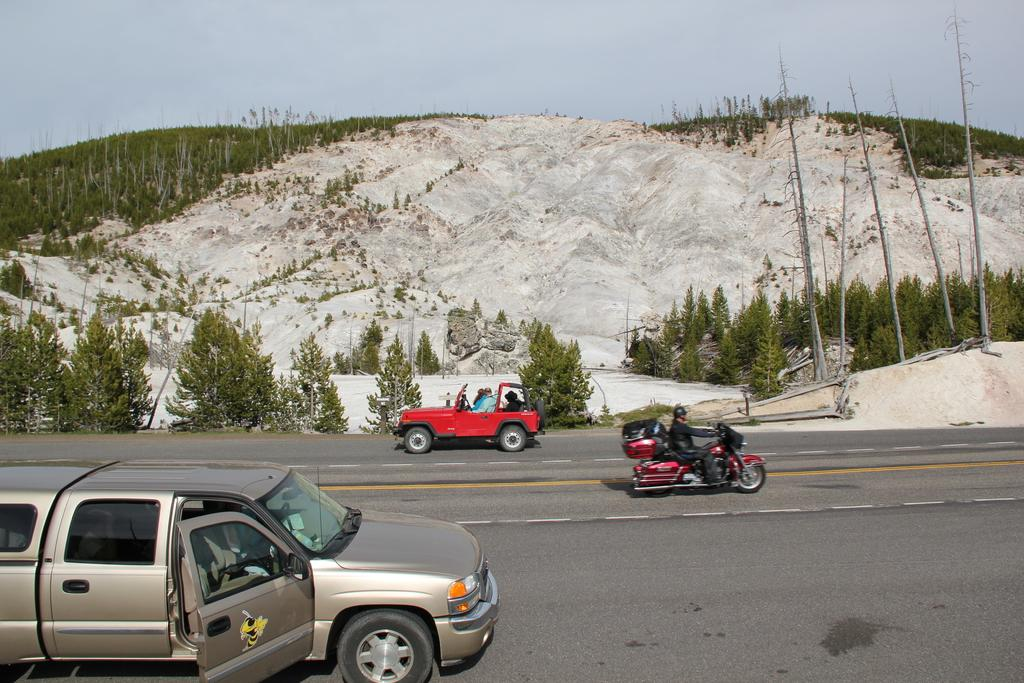What can be seen in the sky in the image? The sky is visible in the image. What type of natural features are present in the image? There are mountains, plants, and trees visible in the image. What man-made objects can be seen in the image? Vehicles are present in the image. Are there any people visible in the image? Yes, people are visible in the image. What activity is a man engaged in within the image? There is a man riding a bike on the road in the image. What type of apparatus is being used by the man to perform a skin graft in the image? There is no man performing a skin graft or using any apparatus in the image. What type of rail system is visible in the image? There is no rail system visible in the image. 